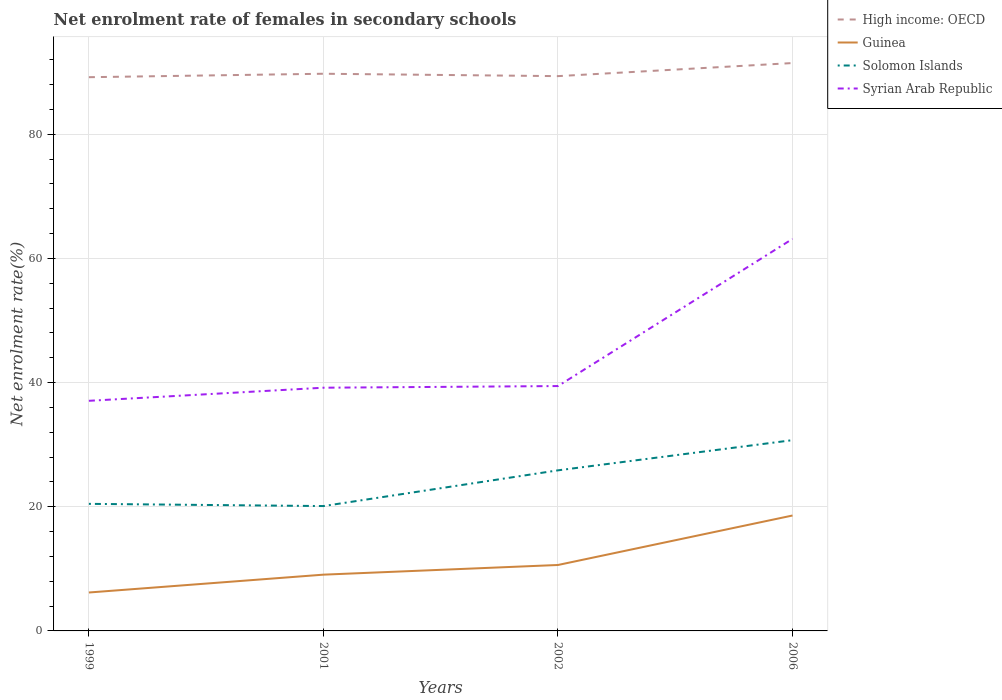How many different coloured lines are there?
Your response must be concise. 4. Across all years, what is the maximum net enrolment rate of females in secondary schools in Solomon Islands?
Offer a very short reply. 20.11. In which year was the net enrolment rate of females in secondary schools in Syrian Arab Republic maximum?
Keep it short and to the point. 1999. What is the total net enrolment rate of females in secondary schools in Guinea in the graph?
Give a very brief answer. -7.97. What is the difference between the highest and the second highest net enrolment rate of females in secondary schools in Syrian Arab Republic?
Keep it short and to the point. 26.08. How many lines are there?
Keep it short and to the point. 4. How many years are there in the graph?
Your answer should be compact. 4. Does the graph contain grids?
Ensure brevity in your answer.  Yes. Where does the legend appear in the graph?
Your answer should be compact. Top right. How many legend labels are there?
Your answer should be compact. 4. How are the legend labels stacked?
Your answer should be very brief. Vertical. What is the title of the graph?
Provide a short and direct response. Net enrolment rate of females in secondary schools. Does "French Polynesia" appear as one of the legend labels in the graph?
Provide a succinct answer. No. What is the label or title of the X-axis?
Ensure brevity in your answer.  Years. What is the label or title of the Y-axis?
Offer a very short reply. Net enrolment rate(%). What is the Net enrolment rate(%) in High income: OECD in 1999?
Provide a succinct answer. 89.2. What is the Net enrolment rate(%) in Guinea in 1999?
Give a very brief answer. 6.19. What is the Net enrolment rate(%) in Solomon Islands in 1999?
Ensure brevity in your answer.  20.47. What is the Net enrolment rate(%) in Syrian Arab Republic in 1999?
Your answer should be compact. 37.07. What is the Net enrolment rate(%) in High income: OECD in 2001?
Ensure brevity in your answer.  89.76. What is the Net enrolment rate(%) of Guinea in 2001?
Offer a terse response. 9.06. What is the Net enrolment rate(%) of Solomon Islands in 2001?
Make the answer very short. 20.11. What is the Net enrolment rate(%) in Syrian Arab Republic in 2001?
Make the answer very short. 39.18. What is the Net enrolment rate(%) in High income: OECD in 2002?
Your answer should be very brief. 89.37. What is the Net enrolment rate(%) in Guinea in 2002?
Ensure brevity in your answer.  10.62. What is the Net enrolment rate(%) of Solomon Islands in 2002?
Your answer should be very brief. 25.87. What is the Net enrolment rate(%) in Syrian Arab Republic in 2002?
Provide a short and direct response. 39.45. What is the Net enrolment rate(%) of High income: OECD in 2006?
Keep it short and to the point. 91.48. What is the Net enrolment rate(%) of Guinea in 2006?
Your answer should be compact. 18.59. What is the Net enrolment rate(%) of Solomon Islands in 2006?
Your response must be concise. 30.73. What is the Net enrolment rate(%) in Syrian Arab Republic in 2006?
Your response must be concise. 63.15. Across all years, what is the maximum Net enrolment rate(%) in High income: OECD?
Make the answer very short. 91.48. Across all years, what is the maximum Net enrolment rate(%) in Guinea?
Offer a terse response. 18.59. Across all years, what is the maximum Net enrolment rate(%) in Solomon Islands?
Your answer should be compact. 30.73. Across all years, what is the maximum Net enrolment rate(%) in Syrian Arab Republic?
Provide a short and direct response. 63.15. Across all years, what is the minimum Net enrolment rate(%) of High income: OECD?
Provide a short and direct response. 89.2. Across all years, what is the minimum Net enrolment rate(%) in Guinea?
Offer a very short reply. 6.19. Across all years, what is the minimum Net enrolment rate(%) of Solomon Islands?
Offer a very short reply. 20.11. Across all years, what is the minimum Net enrolment rate(%) of Syrian Arab Republic?
Keep it short and to the point. 37.07. What is the total Net enrolment rate(%) of High income: OECD in the graph?
Ensure brevity in your answer.  359.81. What is the total Net enrolment rate(%) of Guinea in the graph?
Keep it short and to the point. 44.47. What is the total Net enrolment rate(%) in Solomon Islands in the graph?
Offer a very short reply. 97.18. What is the total Net enrolment rate(%) in Syrian Arab Republic in the graph?
Provide a short and direct response. 178.85. What is the difference between the Net enrolment rate(%) in High income: OECD in 1999 and that in 2001?
Your answer should be very brief. -0.56. What is the difference between the Net enrolment rate(%) in Guinea in 1999 and that in 2001?
Offer a terse response. -2.87. What is the difference between the Net enrolment rate(%) of Solomon Islands in 1999 and that in 2001?
Make the answer very short. 0.36. What is the difference between the Net enrolment rate(%) of Syrian Arab Republic in 1999 and that in 2001?
Your response must be concise. -2.11. What is the difference between the Net enrolment rate(%) in High income: OECD in 1999 and that in 2002?
Offer a terse response. -0.17. What is the difference between the Net enrolment rate(%) of Guinea in 1999 and that in 2002?
Provide a short and direct response. -4.43. What is the difference between the Net enrolment rate(%) in Solomon Islands in 1999 and that in 2002?
Make the answer very short. -5.4. What is the difference between the Net enrolment rate(%) in Syrian Arab Republic in 1999 and that in 2002?
Your answer should be very brief. -2.38. What is the difference between the Net enrolment rate(%) of High income: OECD in 1999 and that in 2006?
Make the answer very short. -2.28. What is the difference between the Net enrolment rate(%) of Guinea in 1999 and that in 2006?
Give a very brief answer. -12.4. What is the difference between the Net enrolment rate(%) of Solomon Islands in 1999 and that in 2006?
Give a very brief answer. -10.26. What is the difference between the Net enrolment rate(%) of Syrian Arab Republic in 1999 and that in 2006?
Keep it short and to the point. -26.08. What is the difference between the Net enrolment rate(%) of High income: OECD in 2001 and that in 2002?
Make the answer very short. 0.38. What is the difference between the Net enrolment rate(%) of Guinea in 2001 and that in 2002?
Give a very brief answer. -1.56. What is the difference between the Net enrolment rate(%) in Solomon Islands in 2001 and that in 2002?
Give a very brief answer. -5.76. What is the difference between the Net enrolment rate(%) of Syrian Arab Republic in 2001 and that in 2002?
Offer a terse response. -0.27. What is the difference between the Net enrolment rate(%) of High income: OECD in 2001 and that in 2006?
Offer a very short reply. -1.72. What is the difference between the Net enrolment rate(%) of Guinea in 2001 and that in 2006?
Your answer should be very brief. -9.53. What is the difference between the Net enrolment rate(%) of Solomon Islands in 2001 and that in 2006?
Provide a short and direct response. -10.62. What is the difference between the Net enrolment rate(%) of Syrian Arab Republic in 2001 and that in 2006?
Offer a terse response. -23.97. What is the difference between the Net enrolment rate(%) in High income: OECD in 2002 and that in 2006?
Make the answer very short. -2.11. What is the difference between the Net enrolment rate(%) in Guinea in 2002 and that in 2006?
Provide a short and direct response. -7.97. What is the difference between the Net enrolment rate(%) of Solomon Islands in 2002 and that in 2006?
Ensure brevity in your answer.  -4.86. What is the difference between the Net enrolment rate(%) of Syrian Arab Republic in 2002 and that in 2006?
Your answer should be compact. -23.71. What is the difference between the Net enrolment rate(%) of High income: OECD in 1999 and the Net enrolment rate(%) of Guinea in 2001?
Offer a very short reply. 80.14. What is the difference between the Net enrolment rate(%) of High income: OECD in 1999 and the Net enrolment rate(%) of Solomon Islands in 2001?
Offer a very short reply. 69.09. What is the difference between the Net enrolment rate(%) of High income: OECD in 1999 and the Net enrolment rate(%) of Syrian Arab Republic in 2001?
Ensure brevity in your answer.  50.02. What is the difference between the Net enrolment rate(%) in Guinea in 1999 and the Net enrolment rate(%) in Solomon Islands in 2001?
Your answer should be compact. -13.92. What is the difference between the Net enrolment rate(%) in Guinea in 1999 and the Net enrolment rate(%) in Syrian Arab Republic in 2001?
Ensure brevity in your answer.  -32.99. What is the difference between the Net enrolment rate(%) in Solomon Islands in 1999 and the Net enrolment rate(%) in Syrian Arab Republic in 2001?
Your answer should be compact. -18.71. What is the difference between the Net enrolment rate(%) in High income: OECD in 1999 and the Net enrolment rate(%) in Guinea in 2002?
Your answer should be compact. 78.58. What is the difference between the Net enrolment rate(%) of High income: OECD in 1999 and the Net enrolment rate(%) of Solomon Islands in 2002?
Provide a succinct answer. 63.33. What is the difference between the Net enrolment rate(%) of High income: OECD in 1999 and the Net enrolment rate(%) of Syrian Arab Republic in 2002?
Provide a succinct answer. 49.75. What is the difference between the Net enrolment rate(%) in Guinea in 1999 and the Net enrolment rate(%) in Solomon Islands in 2002?
Keep it short and to the point. -19.68. What is the difference between the Net enrolment rate(%) of Guinea in 1999 and the Net enrolment rate(%) of Syrian Arab Republic in 2002?
Offer a very short reply. -33.26. What is the difference between the Net enrolment rate(%) of Solomon Islands in 1999 and the Net enrolment rate(%) of Syrian Arab Republic in 2002?
Your answer should be compact. -18.98. What is the difference between the Net enrolment rate(%) of High income: OECD in 1999 and the Net enrolment rate(%) of Guinea in 2006?
Your answer should be very brief. 70.61. What is the difference between the Net enrolment rate(%) of High income: OECD in 1999 and the Net enrolment rate(%) of Solomon Islands in 2006?
Your response must be concise. 58.47. What is the difference between the Net enrolment rate(%) in High income: OECD in 1999 and the Net enrolment rate(%) in Syrian Arab Republic in 2006?
Ensure brevity in your answer.  26.05. What is the difference between the Net enrolment rate(%) in Guinea in 1999 and the Net enrolment rate(%) in Solomon Islands in 2006?
Keep it short and to the point. -24.54. What is the difference between the Net enrolment rate(%) in Guinea in 1999 and the Net enrolment rate(%) in Syrian Arab Republic in 2006?
Your answer should be compact. -56.96. What is the difference between the Net enrolment rate(%) of Solomon Islands in 1999 and the Net enrolment rate(%) of Syrian Arab Republic in 2006?
Provide a succinct answer. -42.68. What is the difference between the Net enrolment rate(%) of High income: OECD in 2001 and the Net enrolment rate(%) of Guinea in 2002?
Offer a terse response. 79.13. What is the difference between the Net enrolment rate(%) in High income: OECD in 2001 and the Net enrolment rate(%) in Solomon Islands in 2002?
Your response must be concise. 63.89. What is the difference between the Net enrolment rate(%) of High income: OECD in 2001 and the Net enrolment rate(%) of Syrian Arab Republic in 2002?
Give a very brief answer. 50.31. What is the difference between the Net enrolment rate(%) in Guinea in 2001 and the Net enrolment rate(%) in Solomon Islands in 2002?
Your response must be concise. -16.81. What is the difference between the Net enrolment rate(%) in Guinea in 2001 and the Net enrolment rate(%) in Syrian Arab Republic in 2002?
Provide a succinct answer. -30.38. What is the difference between the Net enrolment rate(%) in Solomon Islands in 2001 and the Net enrolment rate(%) in Syrian Arab Republic in 2002?
Your response must be concise. -19.33. What is the difference between the Net enrolment rate(%) of High income: OECD in 2001 and the Net enrolment rate(%) of Guinea in 2006?
Provide a succinct answer. 71.16. What is the difference between the Net enrolment rate(%) of High income: OECD in 2001 and the Net enrolment rate(%) of Solomon Islands in 2006?
Provide a succinct answer. 59.03. What is the difference between the Net enrolment rate(%) of High income: OECD in 2001 and the Net enrolment rate(%) of Syrian Arab Republic in 2006?
Your answer should be very brief. 26.61. What is the difference between the Net enrolment rate(%) in Guinea in 2001 and the Net enrolment rate(%) in Solomon Islands in 2006?
Provide a succinct answer. -21.67. What is the difference between the Net enrolment rate(%) in Guinea in 2001 and the Net enrolment rate(%) in Syrian Arab Republic in 2006?
Keep it short and to the point. -54.09. What is the difference between the Net enrolment rate(%) of Solomon Islands in 2001 and the Net enrolment rate(%) of Syrian Arab Republic in 2006?
Give a very brief answer. -43.04. What is the difference between the Net enrolment rate(%) of High income: OECD in 2002 and the Net enrolment rate(%) of Guinea in 2006?
Offer a very short reply. 70.78. What is the difference between the Net enrolment rate(%) of High income: OECD in 2002 and the Net enrolment rate(%) of Solomon Islands in 2006?
Offer a very short reply. 58.64. What is the difference between the Net enrolment rate(%) of High income: OECD in 2002 and the Net enrolment rate(%) of Syrian Arab Republic in 2006?
Your answer should be very brief. 26.22. What is the difference between the Net enrolment rate(%) in Guinea in 2002 and the Net enrolment rate(%) in Solomon Islands in 2006?
Offer a very short reply. -20.11. What is the difference between the Net enrolment rate(%) in Guinea in 2002 and the Net enrolment rate(%) in Syrian Arab Republic in 2006?
Offer a very short reply. -52.53. What is the difference between the Net enrolment rate(%) in Solomon Islands in 2002 and the Net enrolment rate(%) in Syrian Arab Republic in 2006?
Make the answer very short. -37.28. What is the average Net enrolment rate(%) of High income: OECD per year?
Ensure brevity in your answer.  89.95. What is the average Net enrolment rate(%) of Guinea per year?
Your answer should be very brief. 11.12. What is the average Net enrolment rate(%) in Solomon Islands per year?
Give a very brief answer. 24.3. What is the average Net enrolment rate(%) of Syrian Arab Republic per year?
Make the answer very short. 44.71. In the year 1999, what is the difference between the Net enrolment rate(%) in High income: OECD and Net enrolment rate(%) in Guinea?
Ensure brevity in your answer.  83.01. In the year 1999, what is the difference between the Net enrolment rate(%) in High income: OECD and Net enrolment rate(%) in Solomon Islands?
Offer a terse response. 68.73. In the year 1999, what is the difference between the Net enrolment rate(%) in High income: OECD and Net enrolment rate(%) in Syrian Arab Republic?
Provide a short and direct response. 52.13. In the year 1999, what is the difference between the Net enrolment rate(%) in Guinea and Net enrolment rate(%) in Solomon Islands?
Your answer should be compact. -14.28. In the year 1999, what is the difference between the Net enrolment rate(%) in Guinea and Net enrolment rate(%) in Syrian Arab Republic?
Provide a short and direct response. -30.88. In the year 1999, what is the difference between the Net enrolment rate(%) of Solomon Islands and Net enrolment rate(%) of Syrian Arab Republic?
Your response must be concise. -16.6. In the year 2001, what is the difference between the Net enrolment rate(%) in High income: OECD and Net enrolment rate(%) in Guinea?
Provide a succinct answer. 80.69. In the year 2001, what is the difference between the Net enrolment rate(%) of High income: OECD and Net enrolment rate(%) of Solomon Islands?
Give a very brief answer. 69.64. In the year 2001, what is the difference between the Net enrolment rate(%) in High income: OECD and Net enrolment rate(%) in Syrian Arab Republic?
Provide a short and direct response. 50.58. In the year 2001, what is the difference between the Net enrolment rate(%) in Guinea and Net enrolment rate(%) in Solomon Islands?
Give a very brief answer. -11.05. In the year 2001, what is the difference between the Net enrolment rate(%) in Guinea and Net enrolment rate(%) in Syrian Arab Republic?
Keep it short and to the point. -30.12. In the year 2001, what is the difference between the Net enrolment rate(%) of Solomon Islands and Net enrolment rate(%) of Syrian Arab Republic?
Offer a terse response. -19.07. In the year 2002, what is the difference between the Net enrolment rate(%) of High income: OECD and Net enrolment rate(%) of Guinea?
Your answer should be very brief. 78.75. In the year 2002, what is the difference between the Net enrolment rate(%) of High income: OECD and Net enrolment rate(%) of Solomon Islands?
Give a very brief answer. 63.5. In the year 2002, what is the difference between the Net enrolment rate(%) in High income: OECD and Net enrolment rate(%) in Syrian Arab Republic?
Make the answer very short. 49.93. In the year 2002, what is the difference between the Net enrolment rate(%) of Guinea and Net enrolment rate(%) of Solomon Islands?
Your answer should be very brief. -15.25. In the year 2002, what is the difference between the Net enrolment rate(%) in Guinea and Net enrolment rate(%) in Syrian Arab Republic?
Your answer should be very brief. -28.82. In the year 2002, what is the difference between the Net enrolment rate(%) in Solomon Islands and Net enrolment rate(%) in Syrian Arab Republic?
Provide a short and direct response. -13.58. In the year 2006, what is the difference between the Net enrolment rate(%) in High income: OECD and Net enrolment rate(%) in Guinea?
Provide a succinct answer. 72.89. In the year 2006, what is the difference between the Net enrolment rate(%) of High income: OECD and Net enrolment rate(%) of Solomon Islands?
Offer a very short reply. 60.75. In the year 2006, what is the difference between the Net enrolment rate(%) of High income: OECD and Net enrolment rate(%) of Syrian Arab Republic?
Your answer should be compact. 28.33. In the year 2006, what is the difference between the Net enrolment rate(%) of Guinea and Net enrolment rate(%) of Solomon Islands?
Keep it short and to the point. -12.14. In the year 2006, what is the difference between the Net enrolment rate(%) in Guinea and Net enrolment rate(%) in Syrian Arab Republic?
Offer a terse response. -44.56. In the year 2006, what is the difference between the Net enrolment rate(%) of Solomon Islands and Net enrolment rate(%) of Syrian Arab Republic?
Ensure brevity in your answer.  -32.42. What is the ratio of the Net enrolment rate(%) in High income: OECD in 1999 to that in 2001?
Your answer should be very brief. 0.99. What is the ratio of the Net enrolment rate(%) of Guinea in 1999 to that in 2001?
Your answer should be very brief. 0.68. What is the ratio of the Net enrolment rate(%) in Solomon Islands in 1999 to that in 2001?
Make the answer very short. 1.02. What is the ratio of the Net enrolment rate(%) of Syrian Arab Republic in 1999 to that in 2001?
Provide a short and direct response. 0.95. What is the ratio of the Net enrolment rate(%) in Guinea in 1999 to that in 2002?
Provide a short and direct response. 0.58. What is the ratio of the Net enrolment rate(%) in Solomon Islands in 1999 to that in 2002?
Your answer should be very brief. 0.79. What is the ratio of the Net enrolment rate(%) in Syrian Arab Republic in 1999 to that in 2002?
Ensure brevity in your answer.  0.94. What is the ratio of the Net enrolment rate(%) in High income: OECD in 1999 to that in 2006?
Your answer should be very brief. 0.98. What is the ratio of the Net enrolment rate(%) of Guinea in 1999 to that in 2006?
Your answer should be compact. 0.33. What is the ratio of the Net enrolment rate(%) of Solomon Islands in 1999 to that in 2006?
Keep it short and to the point. 0.67. What is the ratio of the Net enrolment rate(%) of Syrian Arab Republic in 1999 to that in 2006?
Your response must be concise. 0.59. What is the ratio of the Net enrolment rate(%) in High income: OECD in 2001 to that in 2002?
Your response must be concise. 1. What is the ratio of the Net enrolment rate(%) in Guinea in 2001 to that in 2002?
Your response must be concise. 0.85. What is the ratio of the Net enrolment rate(%) in Solomon Islands in 2001 to that in 2002?
Provide a short and direct response. 0.78. What is the ratio of the Net enrolment rate(%) of Syrian Arab Republic in 2001 to that in 2002?
Your response must be concise. 0.99. What is the ratio of the Net enrolment rate(%) of High income: OECD in 2001 to that in 2006?
Provide a succinct answer. 0.98. What is the ratio of the Net enrolment rate(%) in Guinea in 2001 to that in 2006?
Make the answer very short. 0.49. What is the ratio of the Net enrolment rate(%) of Solomon Islands in 2001 to that in 2006?
Make the answer very short. 0.65. What is the ratio of the Net enrolment rate(%) of Syrian Arab Republic in 2001 to that in 2006?
Give a very brief answer. 0.62. What is the ratio of the Net enrolment rate(%) in High income: OECD in 2002 to that in 2006?
Provide a short and direct response. 0.98. What is the ratio of the Net enrolment rate(%) of Guinea in 2002 to that in 2006?
Offer a terse response. 0.57. What is the ratio of the Net enrolment rate(%) in Solomon Islands in 2002 to that in 2006?
Your answer should be compact. 0.84. What is the ratio of the Net enrolment rate(%) in Syrian Arab Republic in 2002 to that in 2006?
Offer a very short reply. 0.62. What is the difference between the highest and the second highest Net enrolment rate(%) of High income: OECD?
Offer a terse response. 1.72. What is the difference between the highest and the second highest Net enrolment rate(%) in Guinea?
Offer a very short reply. 7.97. What is the difference between the highest and the second highest Net enrolment rate(%) in Solomon Islands?
Offer a very short reply. 4.86. What is the difference between the highest and the second highest Net enrolment rate(%) of Syrian Arab Republic?
Offer a very short reply. 23.71. What is the difference between the highest and the lowest Net enrolment rate(%) in High income: OECD?
Keep it short and to the point. 2.28. What is the difference between the highest and the lowest Net enrolment rate(%) in Guinea?
Provide a succinct answer. 12.4. What is the difference between the highest and the lowest Net enrolment rate(%) in Solomon Islands?
Your response must be concise. 10.62. What is the difference between the highest and the lowest Net enrolment rate(%) in Syrian Arab Republic?
Ensure brevity in your answer.  26.08. 